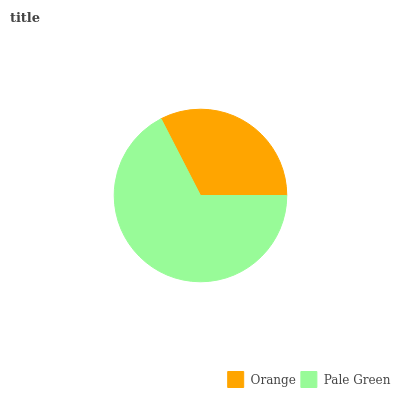Is Orange the minimum?
Answer yes or no. Yes. Is Pale Green the maximum?
Answer yes or no. Yes. Is Pale Green the minimum?
Answer yes or no. No. Is Pale Green greater than Orange?
Answer yes or no. Yes. Is Orange less than Pale Green?
Answer yes or no. Yes. Is Orange greater than Pale Green?
Answer yes or no. No. Is Pale Green less than Orange?
Answer yes or no. No. Is Pale Green the high median?
Answer yes or no. Yes. Is Orange the low median?
Answer yes or no. Yes. Is Orange the high median?
Answer yes or no. No. Is Pale Green the low median?
Answer yes or no. No. 